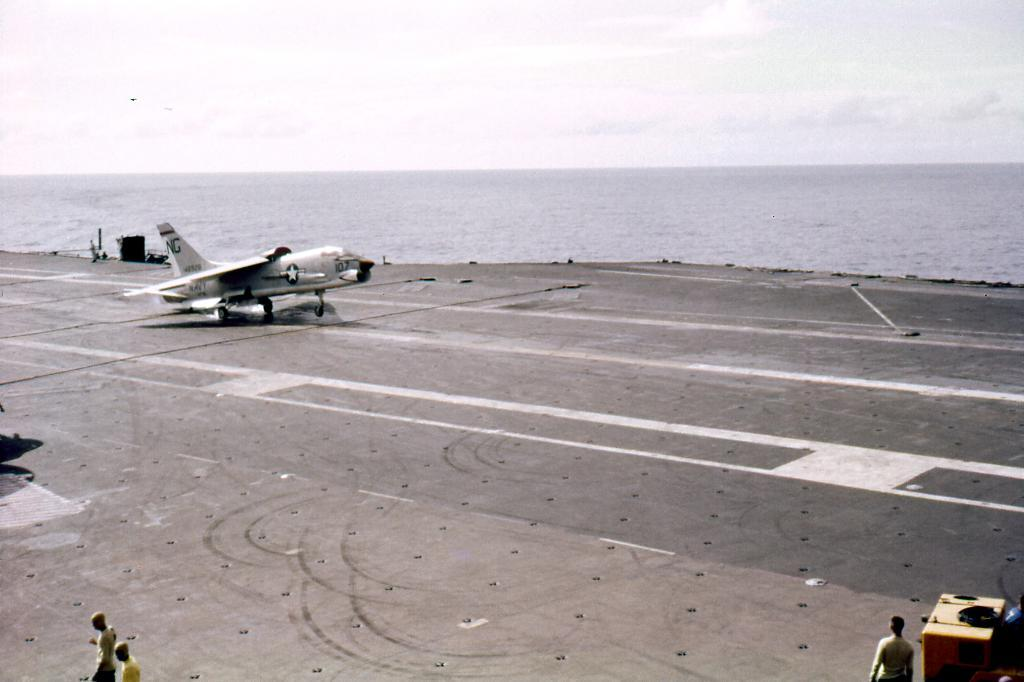What is the main subject of the image? The main subject of the image is an aeroplane on a war ship. Can you describe the people in the image? There are persons visible at the bottom of the image. What can be seen in the background of the image? There are clouds, the sky, and water visible in the background of the image. How many trains can be seen in the image? There are no trains present in the image. What type of wing is attached to the bee in the image? There is no bee present in the image, and therefore no wing can be observed. 